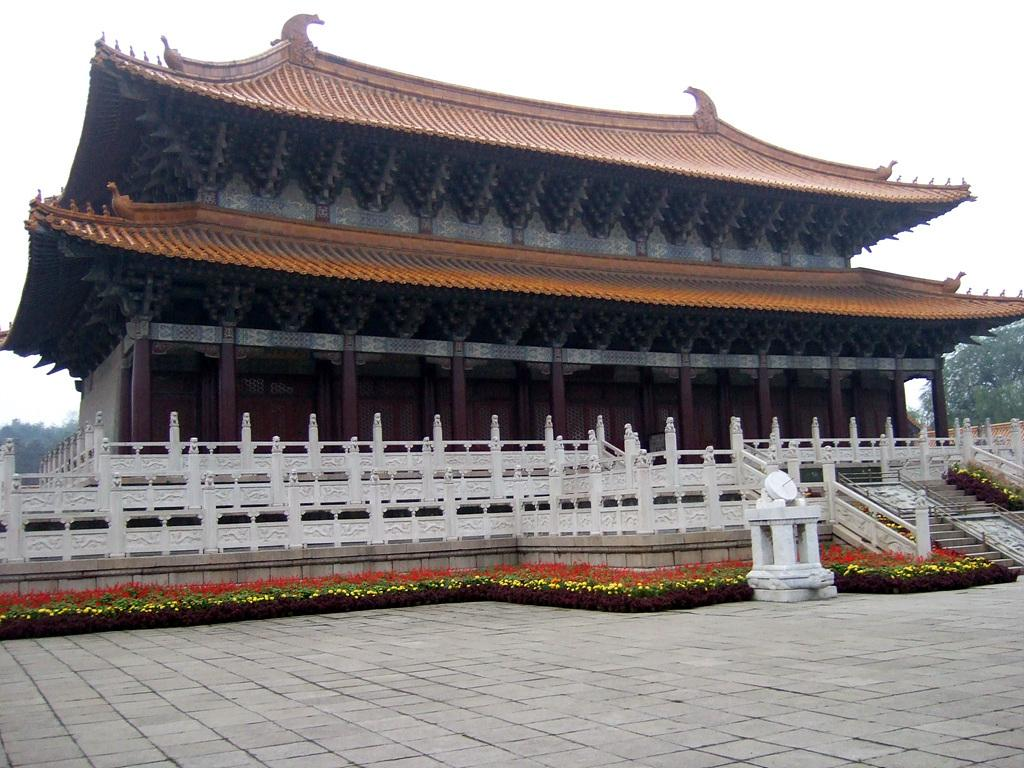What type of surface is visible in the image? There is a pavement in the image. What living organisms can be seen in the image? There are plants and trees visible in the image. What can be seen in the background of the image? There is an architectural structure, trees, and the sky visible in the background of the image. What type of grape is being used as a paperweight on the secretary's desk in the image? There is no secretary or desk present in the image, and therefore no grape being used as a paperweight. 